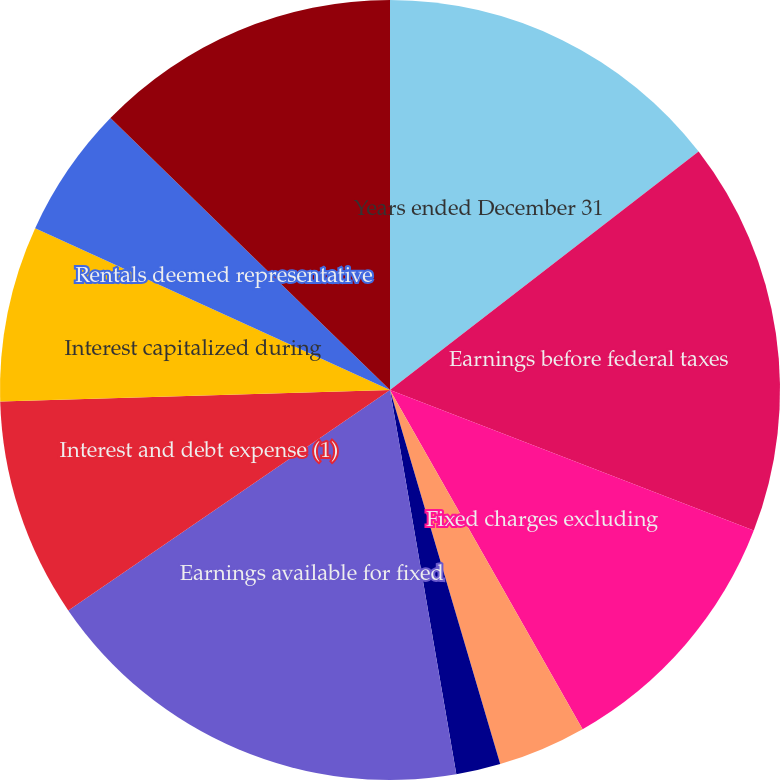Convert chart. <chart><loc_0><loc_0><loc_500><loc_500><pie_chart><fcel>Years ended December 31<fcel>Earnings before federal taxes<fcel>Fixed charges excluding<fcel>Amortization of previously<fcel>Net adjustment for<fcel>Earnings available for fixed<fcel>Interest and debt expense (1)<fcel>Interest capitalized during<fcel>Rentals deemed representative<fcel>Total fixed charges<nl><fcel>14.53%<fcel>16.34%<fcel>10.91%<fcel>3.66%<fcel>1.84%<fcel>18.16%<fcel>9.09%<fcel>7.28%<fcel>5.47%<fcel>12.72%<nl></chart> 